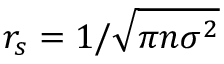<formula> <loc_0><loc_0><loc_500><loc_500>r _ { s } = 1 / \sqrt { \pi n \sigma ^ { 2 } }</formula> 